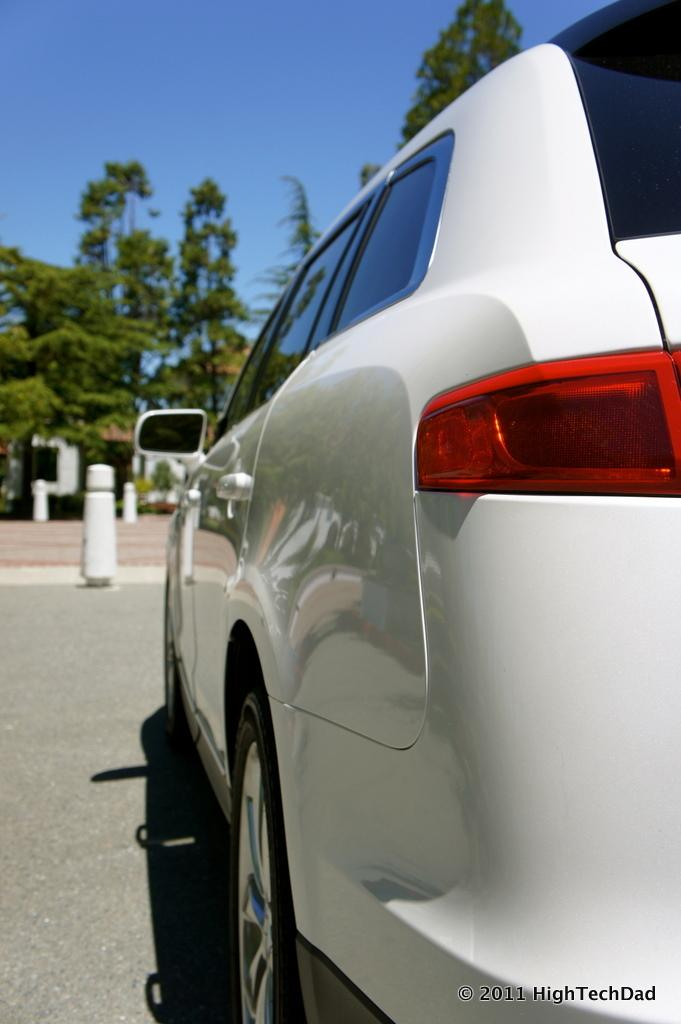What is the main subject of the image? There is a car in the image. What can be seen in the background of the image? The sky is visible in the background of the image. What objects are present in the back of the image? There are small poles in the back of the image. What type of natural elements can be seen in the image? Trees are present in the image. What type of milk is being poured into the car in the image? There is no milk or pouring action present in the image; it features a car with small poles, trees, and the sky in the background. 